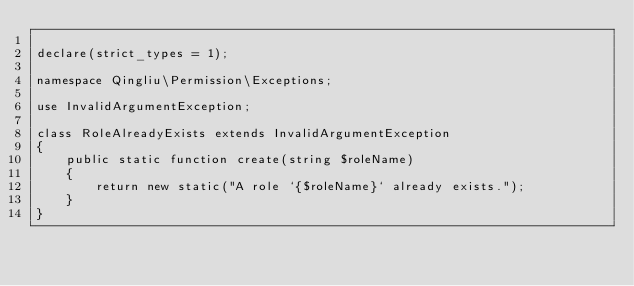<code> <loc_0><loc_0><loc_500><loc_500><_PHP_>
declare(strict_types = 1);

namespace Qingliu\Permission\Exceptions;

use InvalidArgumentException;

class RoleAlreadyExists extends InvalidArgumentException
{
    public static function create(string $roleName)
    {
        return new static("A role `{$roleName}` already exists.");
    }
}
</code> 